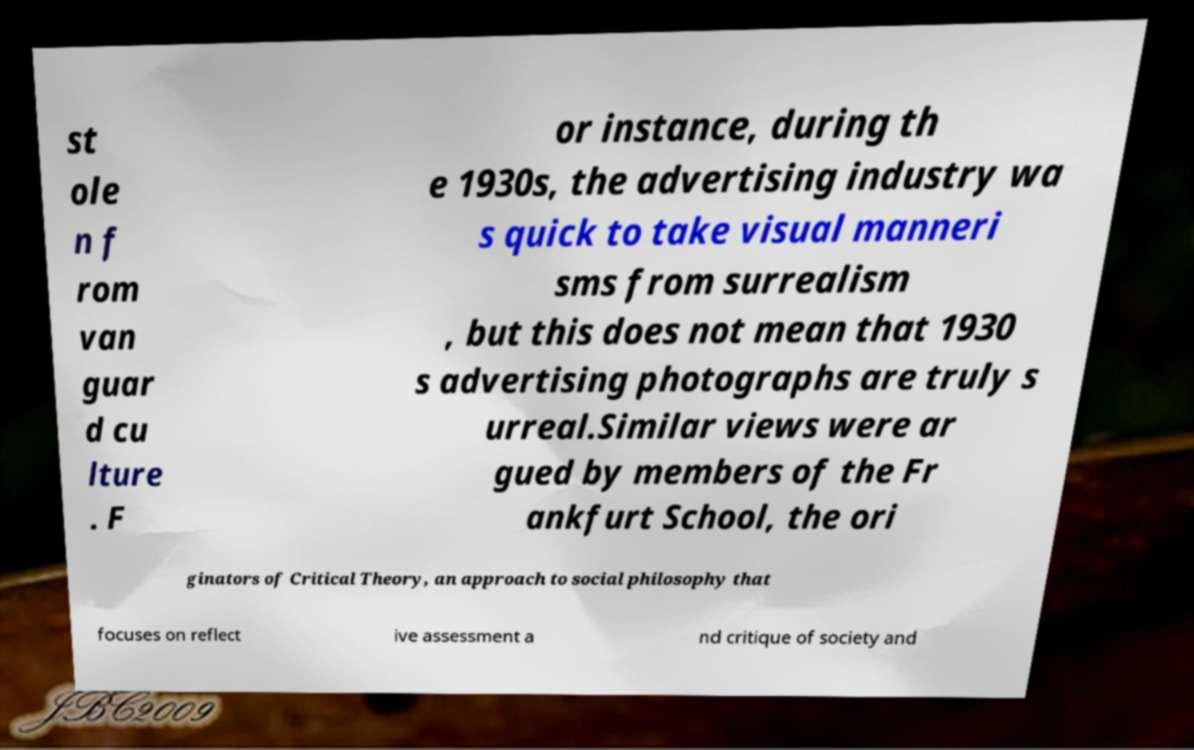What messages or text are displayed in this image? I need them in a readable, typed format. st ole n f rom van guar d cu lture . F or instance, during th e 1930s, the advertising industry wa s quick to take visual manneri sms from surrealism , but this does not mean that 1930 s advertising photographs are truly s urreal.Similar views were ar gued by members of the Fr ankfurt School, the ori ginators of Critical Theory, an approach to social philosophy that focuses on reflect ive assessment a nd critique of society and 